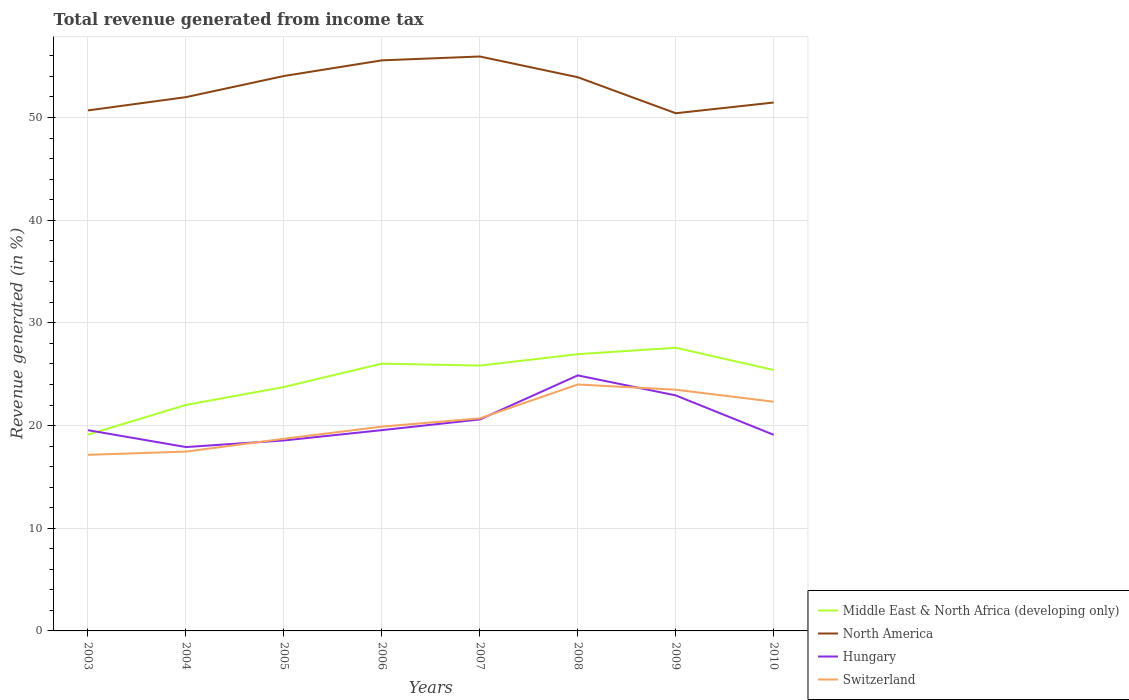Does the line corresponding to Switzerland intersect with the line corresponding to Hungary?
Your response must be concise. Yes. Across all years, what is the maximum total revenue generated in Switzerland?
Provide a short and direct response. 17.15. In which year was the total revenue generated in Middle East & North Africa (developing only) maximum?
Your response must be concise. 2003. What is the total total revenue generated in Middle East & North Africa (developing only) in the graph?
Provide a succinct answer. -0.63. What is the difference between the highest and the second highest total revenue generated in Middle East & North Africa (developing only)?
Offer a terse response. 8.46. What is the difference between the highest and the lowest total revenue generated in Hungary?
Provide a succinct answer. 3. Is the total revenue generated in North America strictly greater than the total revenue generated in Middle East & North Africa (developing only) over the years?
Your answer should be compact. No. How many lines are there?
Provide a short and direct response. 4. Are the values on the major ticks of Y-axis written in scientific E-notation?
Your answer should be very brief. No. Does the graph contain any zero values?
Your response must be concise. No. Does the graph contain grids?
Ensure brevity in your answer.  Yes. Where does the legend appear in the graph?
Keep it short and to the point. Bottom right. How are the legend labels stacked?
Make the answer very short. Vertical. What is the title of the graph?
Ensure brevity in your answer.  Total revenue generated from income tax. What is the label or title of the Y-axis?
Ensure brevity in your answer.  Revenue generated (in %). What is the Revenue generated (in %) of Middle East & North Africa (developing only) in 2003?
Make the answer very short. 19.12. What is the Revenue generated (in %) of North America in 2003?
Your answer should be compact. 50.69. What is the Revenue generated (in %) in Hungary in 2003?
Provide a succinct answer. 19.55. What is the Revenue generated (in %) of Switzerland in 2003?
Give a very brief answer. 17.15. What is the Revenue generated (in %) of Middle East & North Africa (developing only) in 2004?
Give a very brief answer. 22.01. What is the Revenue generated (in %) in North America in 2004?
Provide a short and direct response. 51.98. What is the Revenue generated (in %) in Hungary in 2004?
Offer a very short reply. 17.9. What is the Revenue generated (in %) in Switzerland in 2004?
Make the answer very short. 17.46. What is the Revenue generated (in %) in Middle East & North Africa (developing only) in 2005?
Ensure brevity in your answer.  23.75. What is the Revenue generated (in %) of North America in 2005?
Make the answer very short. 54.04. What is the Revenue generated (in %) of Hungary in 2005?
Provide a succinct answer. 18.55. What is the Revenue generated (in %) of Switzerland in 2005?
Ensure brevity in your answer.  18.71. What is the Revenue generated (in %) of Middle East & North Africa (developing only) in 2006?
Give a very brief answer. 26.03. What is the Revenue generated (in %) in North America in 2006?
Provide a short and direct response. 55.56. What is the Revenue generated (in %) in Hungary in 2006?
Offer a very short reply. 19.55. What is the Revenue generated (in %) of Switzerland in 2006?
Provide a short and direct response. 19.89. What is the Revenue generated (in %) of Middle East & North Africa (developing only) in 2007?
Provide a short and direct response. 25.84. What is the Revenue generated (in %) in North America in 2007?
Provide a succinct answer. 55.94. What is the Revenue generated (in %) of Hungary in 2007?
Keep it short and to the point. 20.59. What is the Revenue generated (in %) of Switzerland in 2007?
Keep it short and to the point. 20.7. What is the Revenue generated (in %) of Middle East & North Africa (developing only) in 2008?
Your answer should be very brief. 26.95. What is the Revenue generated (in %) in North America in 2008?
Offer a very short reply. 53.92. What is the Revenue generated (in %) in Hungary in 2008?
Ensure brevity in your answer.  24.88. What is the Revenue generated (in %) of Switzerland in 2008?
Ensure brevity in your answer.  24. What is the Revenue generated (in %) of Middle East & North Africa (developing only) in 2009?
Offer a terse response. 27.57. What is the Revenue generated (in %) of North America in 2009?
Your answer should be very brief. 50.41. What is the Revenue generated (in %) in Hungary in 2009?
Offer a terse response. 22.93. What is the Revenue generated (in %) in Switzerland in 2009?
Give a very brief answer. 23.49. What is the Revenue generated (in %) of Middle East & North Africa (developing only) in 2010?
Ensure brevity in your answer.  25.41. What is the Revenue generated (in %) of North America in 2010?
Give a very brief answer. 51.46. What is the Revenue generated (in %) in Hungary in 2010?
Your answer should be very brief. 19.1. What is the Revenue generated (in %) in Switzerland in 2010?
Your answer should be compact. 22.32. Across all years, what is the maximum Revenue generated (in %) in Middle East & North Africa (developing only)?
Provide a succinct answer. 27.57. Across all years, what is the maximum Revenue generated (in %) in North America?
Offer a very short reply. 55.94. Across all years, what is the maximum Revenue generated (in %) in Hungary?
Give a very brief answer. 24.88. Across all years, what is the maximum Revenue generated (in %) of Switzerland?
Offer a very short reply. 24. Across all years, what is the minimum Revenue generated (in %) of Middle East & North Africa (developing only)?
Offer a very short reply. 19.12. Across all years, what is the minimum Revenue generated (in %) in North America?
Offer a very short reply. 50.41. Across all years, what is the minimum Revenue generated (in %) of Hungary?
Give a very brief answer. 17.9. Across all years, what is the minimum Revenue generated (in %) in Switzerland?
Your answer should be very brief. 17.15. What is the total Revenue generated (in %) in Middle East & North Africa (developing only) in the graph?
Your answer should be very brief. 196.67. What is the total Revenue generated (in %) of North America in the graph?
Offer a terse response. 423.99. What is the total Revenue generated (in %) in Hungary in the graph?
Your answer should be very brief. 163.06. What is the total Revenue generated (in %) of Switzerland in the graph?
Offer a terse response. 163.73. What is the difference between the Revenue generated (in %) in Middle East & North Africa (developing only) in 2003 and that in 2004?
Keep it short and to the point. -2.89. What is the difference between the Revenue generated (in %) in North America in 2003 and that in 2004?
Keep it short and to the point. -1.29. What is the difference between the Revenue generated (in %) in Hungary in 2003 and that in 2004?
Your answer should be compact. 1.64. What is the difference between the Revenue generated (in %) in Switzerland in 2003 and that in 2004?
Offer a very short reply. -0.31. What is the difference between the Revenue generated (in %) in Middle East & North Africa (developing only) in 2003 and that in 2005?
Your answer should be very brief. -4.64. What is the difference between the Revenue generated (in %) in North America in 2003 and that in 2005?
Your answer should be very brief. -3.35. What is the difference between the Revenue generated (in %) in Hungary in 2003 and that in 2005?
Offer a very short reply. 1. What is the difference between the Revenue generated (in %) in Switzerland in 2003 and that in 2005?
Make the answer very short. -1.56. What is the difference between the Revenue generated (in %) in Middle East & North Africa (developing only) in 2003 and that in 2006?
Provide a short and direct response. -6.91. What is the difference between the Revenue generated (in %) in North America in 2003 and that in 2006?
Ensure brevity in your answer.  -4.88. What is the difference between the Revenue generated (in %) of Hungary in 2003 and that in 2006?
Offer a terse response. -0. What is the difference between the Revenue generated (in %) in Switzerland in 2003 and that in 2006?
Provide a short and direct response. -2.75. What is the difference between the Revenue generated (in %) of Middle East & North Africa (developing only) in 2003 and that in 2007?
Give a very brief answer. -6.72. What is the difference between the Revenue generated (in %) of North America in 2003 and that in 2007?
Make the answer very short. -5.25. What is the difference between the Revenue generated (in %) in Hungary in 2003 and that in 2007?
Your answer should be compact. -1.05. What is the difference between the Revenue generated (in %) in Switzerland in 2003 and that in 2007?
Your answer should be very brief. -3.55. What is the difference between the Revenue generated (in %) in Middle East & North Africa (developing only) in 2003 and that in 2008?
Make the answer very short. -7.83. What is the difference between the Revenue generated (in %) in North America in 2003 and that in 2008?
Ensure brevity in your answer.  -3.23. What is the difference between the Revenue generated (in %) of Hungary in 2003 and that in 2008?
Offer a terse response. -5.34. What is the difference between the Revenue generated (in %) of Switzerland in 2003 and that in 2008?
Provide a short and direct response. -6.85. What is the difference between the Revenue generated (in %) of Middle East & North Africa (developing only) in 2003 and that in 2009?
Provide a succinct answer. -8.46. What is the difference between the Revenue generated (in %) of North America in 2003 and that in 2009?
Your answer should be very brief. 0.27. What is the difference between the Revenue generated (in %) in Hungary in 2003 and that in 2009?
Offer a very short reply. -3.39. What is the difference between the Revenue generated (in %) in Switzerland in 2003 and that in 2009?
Ensure brevity in your answer.  -6.34. What is the difference between the Revenue generated (in %) in Middle East & North Africa (developing only) in 2003 and that in 2010?
Offer a terse response. -6.3. What is the difference between the Revenue generated (in %) of North America in 2003 and that in 2010?
Your answer should be compact. -0.77. What is the difference between the Revenue generated (in %) of Hungary in 2003 and that in 2010?
Provide a short and direct response. 0.45. What is the difference between the Revenue generated (in %) of Switzerland in 2003 and that in 2010?
Give a very brief answer. -5.17. What is the difference between the Revenue generated (in %) of Middle East & North Africa (developing only) in 2004 and that in 2005?
Offer a very short reply. -1.74. What is the difference between the Revenue generated (in %) of North America in 2004 and that in 2005?
Your answer should be very brief. -2.06. What is the difference between the Revenue generated (in %) in Hungary in 2004 and that in 2005?
Provide a succinct answer. -0.64. What is the difference between the Revenue generated (in %) of Switzerland in 2004 and that in 2005?
Provide a short and direct response. -1.25. What is the difference between the Revenue generated (in %) of Middle East & North Africa (developing only) in 2004 and that in 2006?
Offer a terse response. -4.02. What is the difference between the Revenue generated (in %) in North America in 2004 and that in 2006?
Provide a succinct answer. -3.58. What is the difference between the Revenue generated (in %) of Hungary in 2004 and that in 2006?
Give a very brief answer. -1.65. What is the difference between the Revenue generated (in %) in Switzerland in 2004 and that in 2006?
Provide a succinct answer. -2.43. What is the difference between the Revenue generated (in %) of Middle East & North Africa (developing only) in 2004 and that in 2007?
Ensure brevity in your answer.  -3.83. What is the difference between the Revenue generated (in %) in North America in 2004 and that in 2007?
Your response must be concise. -3.96. What is the difference between the Revenue generated (in %) of Hungary in 2004 and that in 2007?
Keep it short and to the point. -2.69. What is the difference between the Revenue generated (in %) in Switzerland in 2004 and that in 2007?
Your response must be concise. -3.24. What is the difference between the Revenue generated (in %) in Middle East & North Africa (developing only) in 2004 and that in 2008?
Keep it short and to the point. -4.94. What is the difference between the Revenue generated (in %) in North America in 2004 and that in 2008?
Your answer should be very brief. -1.94. What is the difference between the Revenue generated (in %) in Hungary in 2004 and that in 2008?
Ensure brevity in your answer.  -6.98. What is the difference between the Revenue generated (in %) of Switzerland in 2004 and that in 2008?
Provide a succinct answer. -6.54. What is the difference between the Revenue generated (in %) of Middle East & North Africa (developing only) in 2004 and that in 2009?
Keep it short and to the point. -5.57. What is the difference between the Revenue generated (in %) in North America in 2004 and that in 2009?
Give a very brief answer. 1.57. What is the difference between the Revenue generated (in %) of Hungary in 2004 and that in 2009?
Provide a short and direct response. -5.03. What is the difference between the Revenue generated (in %) in Switzerland in 2004 and that in 2009?
Offer a terse response. -6.03. What is the difference between the Revenue generated (in %) in Middle East & North Africa (developing only) in 2004 and that in 2010?
Give a very brief answer. -3.4. What is the difference between the Revenue generated (in %) of North America in 2004 and that in 2010?
Your answer should be very brief. 0.52. What is the difference between the Revenue generated (in %) in Hungary in 2004 and that in 2010?
Give a very brief answer. -1.19. What is the difference between the Revenue generated (in %) of Switzerland in 2004 and that in 2010?
Your response must be concise. -4.86. What is the difference between the Revenue generated (in %) of Middle East & North Africa (developing only) in 2005 and that in 2006?
Keep it short and to the point. -2.28. What is the difference between the Revenue generated (in %) in North America in 2005 and that in 2006?
Provide a short and direct response. -1.52. What is the difference between the Revenue generated (in %) of Hungary in 2005 and that in 2006?
Provide a succinct answer. -1. What is the difference between the Revenue generated (in %) of Switzerland in 2005 and that in 2006?
Keep it short and to the point. -1.18. What is the difference between the Revenue generated (in %) of Middle East & North Africa (developing only) in 2005 and that in 2007?
Keep it short and to the point. -2.09. What is the difference between the Revenue generated (in %) of Hungary in 2005 and that in 2007?
Provide a succinct answer. -2.05. What is the difference between the Revenue generated (in %) of Switzerland in 2005 and that in 2007?
Provide a succinct answer. -1.99. What is the difference between the Revenue generated (in %) of Middle East & North Africa (developing only) in 2005 and that in 2008?
Keep it short and to the point. -3.2. What is the difference between the Revenue generated (in %) of North America in 2005 and that in 2008?
Offer a very short reply. 0.12. What is the difference between the Revenue generated (in %) in Hungary in 2005 and that in 2008?
Your answer should be very brief. -6.34. What is the difference between the Revenue generated (in %) in Switzerland in 2005 and that in 2008?
Ensure brevity in your answer.  -5.29. What is the difference between the Revenue generated (in %) of Middle East & North Africa (developing only) in 2005 and that in 2009?
Give a very brief answer. -3.82. What is the difference between the Revenue generated (in %) of North America in 2005 and that in 2009?
Ensure brevity in your answer.  3.63. What is the difference between the Revenue generated (in %) of Hungary in 2005 and that in 2009?
Provide a short and direct response. -4.39. What is the difference between the Revenue generated (in %) in Switzerland in 2005 and that in 2009?
Make the answer very short. -4.78. What is the difference between the Revenue generated (in %) of Middle East & North Africa (developing only) in 2005 and that in 2010?
Your answer should be very brief. -1.66. What is the difference between the Revenue generated (in %) of North America in 2005 and that in 2010?
Provide a succinct answer. 2.58. What is the difference between the Revenue generated (in %) in Hungary in 2005 and that in 2010?
Your answer should be very brief. -0.55. What is the difference between the Revenue generated (in %) in Switzerland in 2005 and that in 2010?
Provide a short and direct response. -3.61. What is the difference between the Revenue generated (in %) of Middle East & North Africa (developing only) in 2006 and that in 2007?
Your response must be concise. 0.19. What is the difference between the Revenue generated (in %) in North America in 2006 and that in 2007?
Keep it short and to the point. -0.38. What is the difference between the Revenue generated (in %) in Hungary in 2006 and that in 2007?
Your answer should be compact. -1.04. What is the difference between the Revenue generated (in %) in Switzerland in 2006 and that in 2007?
Ensure brevity in your answer.  -0.81. What is the difference between the Revenue generated (in %) in Middle East & North Africa (developing only) in 2006 and that in 2008?
Your response must be concise. -0.92. What is the difference between the Revenue generated (in %) in North America in 2006 and that in 2008?
Offer a terse response. 1.64. What is the difference between the Revenue generated (in %) of Hungary in 2006 and that in 2008?
Ensure brevity in your answer.  -5.33. What is the difference between the Revenue generated (in %) in Switzerland in 2006 and that in 2008?
Provide a succinct answer. -4.1. What is the difference between the Revenue generated (in %) in Middle East & North Africa (developing only) in 2006 and that in 2009?
Keep it short and to the point. -1.55. What is the difference between the Revenue generated (in %) of North America in 2006 and that in 2009?
Provide a short and direct response. 5.15. What is the difference between the Revenue generated (in %) in Hungary in 2006 and that in 2009?
Keep it short and to the point. -3.38. What is the difference between the Revenue generated (in %) of Switzerland in 2006 and that in 2009?
Your response must be concise. -3.59. What is the difference between the Revenue generated (in %) of Middle East & North Africa (developing only) in 2006 and that in 2010?
Your answer should be compact. 0.62. What is the difference between the Revenue generated (in %) of North America in 2006 and that in 2010?
Ensure brevity in your answer.  4.11. What is the difference between the Revenue generated (in %) in Hungary in 2006 and that in 2010?
Make the answer very short. 0.45. What is the difference between the Revenue generated (in %) of Switzerland in 2006 and that in 2010?
Provide a short and direct response. -2.43. What is the difference between the Revenue generated (in %) of Middle East & North Africa (developing only) in 2007 and that in 2008?
Make the answer very short. -1.11. What is the difference between the Revenue generated (in %) of North America in 2007 and that in 2008?
Give a very brief answer. 2.02. What is the difference between the Revenue generated (in %) in Hungary in 2007 and that in 2008?
Provide a succinct answer. -4.29. What is the difference between the Revenue generated (in %) of Switzerland in 2007 and that in 2008?
Your answer should be very brief. -3.3. What is the difference between the Revenue generated (in %) of Middle East & North Africa (developing only) in 2007 and that in 2009?
Offer a very short reply. -1.74. What is the difference between the Revenue generated (in %) of North America in 2007 and that in 2009?
Your answer should be compact. 5.53. What is the difference between the Revenue generated (in %) in Hungary in 2007 and that in 2009?
Make the answer very short. -2.34. What is the difference between the Revenue generated (in %) in Switzerland in 2007 and that in 2009?
Make the answer very short. -2.79. What is the difference between the Revenue generated (in %) of Middle East & North Africa (developing only) in 2007 and that in 2010?
Provide a succinct answer. 0.43. What is the difference between the Revenue generated (in %) of North America in 2007 and that in 2010?
Keep it short and to the point. 4.48. What is the difference between the Revenue generated (in %) of Hungary in 2007 and that in 2010?
Your response must be concise. 1.5. What is the difference between the Revenue generated (in %) in Switzerland in 2007 and that in 2010?
Ensure brevity in your answer.  -1.62. What is the difference between the Revenue generated (in %) in Middle East & North Africa (developing only) in 2008 and that in 2009?
Provide a succinct answer. -0.63. What is the difference between the Revenue generated (in %) in North America in 2008 and that in 2009?
Provide a short and direct response. 3.51. What is the difference between the Revenue generated (in %) in Hungary in 2008 and that in 2009?
Give a very brief answer. 1.95. What is the difference between the Revenue generated (in %) in Switzerland in 2008 and that in 2009?
Provide a succinct answer. 0.51. What is the difference between the Revenue generated (in %) of Middle East & North Africa (developing only) in 2008 and that in 2010?
Make the answer very short. 1.54. What is the difference between the Revenue generated (in %) in North America in 2008 and that in 2010?
Your response must be concise. 2.46. What is the difference between the Revenue generated (in %) in Hungary in 2008 and that in 2010?
Your answer should be compact. 5.79. What is the difference between the Revenue generated (in %) of Switzerland in 2008 and that in 2010?
Your answer should be very brief. 1.68. What is the difference between the Revenue generated (in %) of Middle East & North Africa (developing only) in 2009 and that in 2010?
Give a very brief answer. 2.16. What is the difference between the Revenue generated (in %) of North America in 2009 and that in 2010?
Provide a short and direct response. -1.04. What is the difference between the Revenue generated (in %) in Hungary in 2009 and that in 2010?
Keep it short and to the point. 3.84. What is the difference between the Revenue generated (in %) of Switzerland in 2009 and that in 2010?
Offer a very short reply. 1.17. What is the difference between the Revenue generated (in %) in Middle East & North Africa (developing only) in 2003 and the Revenue generated (in %) in North America in 2004?
Make the answer very short. -32.86. What is the difference between the Revenue generated (in %) of Middle East & North Africa (developing only) in 2003 and the Revenue generated (in %) of Hungary in 2004?
Keep it short and to the point. 1.21. What is the difference between the Revenue generated (in %) of Middle East & North Africa (developing only) in 2003 and the Revenue generated (in %) of Switzerland in 2004?
Provide a succinct answer. 1.65. What is the difference between the Revenue generated (in %) of North America in 2003 and the Revenue generated (in %) of Hungary in 2004?
Your response must be concise. 32.78. What is the difference between the Revenue generated (in %) in North America in 2003 and the Revenue generated (in %) in Switzerland in 2004?
Ensure brevity in your answer.  33.22. What is the difference between the Revenue generated (in %) in Hungary in 2003 and the Revenue generated (in %) in Switzerland in 2004?
Your response must be concise. 2.09. What is the difference between the Revenue generated (in %) in Middle East & North Africa (developing only) in 2003 and the Revenue generated (in %) in North America in 2005?
Ensure brevity in your answer.  -34.92. What is the difference between the Revenue generated (in %) of Middle East & North Africa (developing only) in 2003 and the Revenue generated (in %) of Hungary in 2005?
Your answer should be compact. 0.57. What is the difference between the Revenue generated (in %) of Middle East & North Africa (developing only) in 2003 and the Revenue generated (in %) of Switzerland in 2005?
Make the answer very short. 0.4. What is the difference between the Revenue generated (in %) in North America in 2003 and the Revenue generated (in %) in Hungary in 2005?
Make the answer very short. 32.14. What is the difference between the Revenue generated (in %) of North America in 2003 and the Revenue generated (in %) of Switzerland in 2005?
Your answer should be very brief. 31.97. What is the difference between the Revenue generated (in %) in Hungary in 2003 and the Revenue generated (in %) in Switzerland in 2005?
Your answer should be very brief. 0.84. What is the difference between the Revenue generated (in %) of Middle East & North Africa (developing only) in 2003 and the Revenue generated (in %) of North America in 2006?
Ensure brevity in your answer.  -36.45. What is the difference between the Revenue generated (in %) in Middle East & North Africa (developing only) in 2003 and the Revenue generated (in %) in Hungary in 2006?
Keep it short and to the point. -0.44. What is the difference between the Revenue generated (in %) in Middle East & North Africa (developing only) in 2003 and the Revenue generated (in %) in Switzerland in 2006?
Your answer should be compact. -0.78. What is the difference between the Revenue generated (in %) of North America in 2003 and the Revenue generated (in %) of Hungary in 2006?
Your answer should be compact. 31.14. What is the difference between the Revenue generated (in %) of North America in 2003 and the Revenue generated (in %) of Switzerland in 2006?
Keep it short and to the point. 30.79. What is the difference between the Revenue generated (in %) in Hungary in 2003 and the Revenue generated (in %) in Switzerland in 2006?
Provide a short and direct response. -0.35. What is the difference between the Revenue generated (in %) in Middle East & North Africa (developing only) in 2003 and the Revenue generated (in %) in North America in 2007?
Give a very brief answer. -36.82. What is the difference between the Revenue generated (in %) in Middle East & North Africa (developing only) in 2003 and the Revenue generated (in %) in Hungary in 2007?
Provide a short and direct response. -1.48. What is the difference between the Revenue generated (in %) in Middle East & North Africa (developing only) in 2003 and the Revenue generated (in %) in Switzerland in 2007?
Make the answer very short. -1.58. What is the difference between the Revenue generated (in %) in North America in 2003 and the Revenue generated (in %) in Hungary in 2007?
Ensure brevity in your answer.  30.09. What is the difference between the Revenue generated (in %) of North America in 2003 and the Revenue generated (in %) of Switzerland in 2007?
Offer a very short reply. 29.99. What is the difference between the Revenue generated (in %) of Hungary in 2003 and the Revenue generated (in %) of Switzerland in 2007?
Your answer should be very brief. -1.15. What is the difference between the Revenue generated (in %) of Middle East & North Africa (developing only) in 2003 and the Revenue generated (in %) of North America in 2008?
Your response must be concise. -34.8. What is the difference between the Revenue generated (in %) of Middle East & North Africa (developing only) in 2003 and the Revenue generated (in %) of Hungary in 2008?
Ensure brevity in your answer.  -5.77. What is the difference between the Revenue generated (in %) of Middle East & North Africa (developing only) in 2003 and the Revenue generated (in %) of Switzerland in 2008?
Offer a terse response. -4.88. What is the difference between the Revenue generated (in %) in North America in 2003 and the Revenue generated (in %) in Hungary in 2008?
Your response must be concise. 25.8. What is the difference between the Revenue generated (in %) of North America in 2003 and the Revenue generated (in %) of Switzerland in 2008?
Make the answer very short. 26.69. What is the difference between the Revenue generated (in %) in Hungary in 2003 and the Revenue generated (in %) in Switzerland in 2008?
Provide a short and direct response. -4.45. What is the difference between the Revenue generated (in %) in Middle East & North Africa (developing only) in 2003 and the Revenue generated (in %) in North America in 2009?
Give a very brief answer. -31.3. What is the difference between the Revenue generated (in %) of Middle East & North Africa (developing only) in 2003 and the Revenue generated (in %) of Hungary in 2009?
Offer a terse response. -3.82. What is the difference between the Revenue generated (in %) of Middle East & North Africa (developing only) in 2003 and the Revenue generated (in %) of Switzerland in 2009?
Give a very brief answer. -4.37. What is the difference between the Revenue generated (in %) of North America in 2003 and the Revenue generated (in %) of Hungary in 2009?
Keep it short and to the point. 27.75. What is the difference between the Revenue generated (in %) in North America in 2003 and the Revenue generated (in %) in Switzerland in 2009?
Make the answer very short. 27.2. What is the difference between the Revenue generated (in %) in Hungary in 2003 and the Revenue generated (in %) in Switzerland in 2009?
Your answer should be very brief. -3.94. What is the difference between the Revenue generated (in %) of Middle East & North Africa (developing only) in 2003 and the Revenue generated (in %) of North America in 2010?
Your answer should be compact. -32.34. What is the difference between the Revenue generated (in %) of Middle East & North Africa (developing only) in 2003 and the Revenue generated (in %) of Hungary in 2010?
Provide a succinct answer. 0.02. What is the difference between the Revenue generated (in %) in Middle East & North Africa (developing only) in 2003 and the Revenue generated (in %) in Switzerland in 2010?
Provide a short and direct response. -3.21. What is the difference between the Revenue generated (in %) of North America in 2003 and the Revenue generated (in %) of Hungary in 2010?
Offer a terse response. 31.59. What is the difference between the Revenue generated (in %) of North America in 2003 and the Revenue generated (in %) of Switzerland in 2010?
Provide a succinct answer. 28.37. What is the difference between the Revenue generated (in %) of Hungary in 2003 and the Revenue generated (in %) of Switzerland in 2010?
Provide a short and direct response. -2.77. What is the difference between the Revenue generated (in %) of Middle East & North Africa (developing only) in 2004 and the Revenue generated (in %) of North America in 2005?
Offer a terse response. -32.03. What is the difference between the Revenue generated (in %) of Middle East & North Africa (developing only) in 2004 and the Revenue generated (in %) of Hungary in 2005?
Make the answer very short. 3.46. What is the difference between the Revenue generated (in %) in Middle East & North Africa (developing only) in 2004 and the Revenue generated (in %) in Switzerland in 2005?
Provide a succinct answer. 3.29. What is the difference between the Revenue generated (in %) of North America in 2004 and the Revenue generated (in %) of Hungary in 2005?
Offer a very short reply. 33.43. What is the difference between the Revenue generated (in %) of North America in 2004 and the Revenue generated (in %) of Switzerland in 2005?
Give a very brief answer. 33.27. What is the difference between the Revenue generated (in %) in Hungary in 2004 and the Revenue generated (in %) in Switzerland in 2005?
Provide a short and direct response. -0.81. What is the difference between the Revenue generated (in %) of Middle East & North Africa (developing only) in 2004 and the Revenue generated (in %) of North America in 2006?
Offer a very short reply. -33.56. What is the difference between the Revenue generated (in %) in Middle East & North Africa (developing only) in 2004 and the Revenue generated (in %) in Hungary in 2006?
Your response must be concise. 2.45. What is the difference between the Revenue generated (in %) in Middle East & North Africa (developing only) in 2004 and the Revenue generated (in %) in Switzerland in 2006?
Make the answer very short. 2.11. What is the difference between the Revenue generated (in %) of North America in 2004 and the Revenue generated (in %) of Hungary in 2006?
Your response must be concise. 32.43. What is the difference between the Revenue generated (in %) in North America in 2004 and the Revenue generated (in %) in Switzerland in 2006?
Your answer should be very brief. 32.09. What is the difference between the Revenue generated (in %) in Hungary in 2004 and the Revenue generated (in %) in Switzerland in 2006?
Ensure brevity in your answer.  -1.99. What is the difference between the Revenue generated (in %) of Middle East & North Africa (developing only) in 2004 and the Revenue generated (in %) of North America in 2007?
Your answer should be very brief. -33.93. What is the difference between the Revenue generated (in %) in Middle East & North Africa (developing only) in 2004 and the Revenue generated (in %) in Hungary in 2007?
Make the answer very short. 1.41. What is the difference between the Revenue generated (in %) in Middle East & North Africa (developing only) in 2004 and the Revenue generated (in %) in Switzerland in 2007?
Keep it short and to the point. 1.31. What is the difference between the Revenue generated (in %) in North America in 2004 and the Revenue generated (in %) in Hungary in 2007?
Provide a succinct answer. 31.39. What is the difference between the Revenue generated (in %) of North America in 2004 and the Revenue generated (in %) of Switzerland in 2007?
Provide a short and direct response. 31.28. What is the difference between the Revenue generated (in %) of Hungary in 2004 and the Revenue generated (in %) of Switzerland in 2007?
Ensure brevity in your answer.  -2.79. What is the difference between the Revenue generated (in %) of Middle East & North Africa (developing only) in 2004 and the Revenue generated (in %) of North America in 2008?
Make the answer very short. -31.91. What is the difference between the Revenue generated (in %) of Middle East & North Africa (developing only) in 2004 and the Revenue generated (in %) of Hungary in 2008?
Your answer should be compact. -2.88. What is the difference between the Revenue generated (in %) in Middle East & North Africa (developing only) in 2004 and the Revenue generated (in %) in Switzerland in 2008?
Your response must be concise. -1.99. What is the difference between the Revenue generated (in %) of North America in 2004 and the Revenue generated (in %) of Hungary in 2008?
Ensure brevity in your answer.  27.1. What is the difference between the Revenue generated (in %) in North America in 2004 and the Revenue generated (in %) in Switzerland in 2008?
Your response must be concise. 27.98. What is the difference between the Revenue generated (in %) of Hungary in 2004 and the Revenue generated (in %) of Switzerland in 2008?
Give a very brief answer. -6.09. What is the difference between the Revenue generated (in %) of Middle East & North Africa (developing only) in 2004 and the Revenue generated (in %) of North America in 2009?
Offer a very short reply. -28.41. What is the difference between the Revenue generated (in %) of Middle East & North Africa (developing only) in 2004 and the Revenue generated (in %) of Hungary in 2009?
Offer a very short reply. -0.93. What is the difference between the Revenue generated (in %) of Middle East & North Africa (developing only) in 2004 and the Revenue generated (in %) of Switzerland in 2009?
Your response must be concise. -1.48. What is the difference between the Revenue generated (in %) in North America in 2004 and the Revenue generated (in %) in Hungary in 2009?
Make the answer very short. 29.05. What is the difference between the Revenue generated (in %) of North America in 2004 and the Revenue generated (in %) of Switzerland in 2009?
Give a very brief answer. 28.49. What is the difference between the Revenue generated (in %) in Hungary in 2004 and the Revenue generated (in %) in Switzerland in 2009?
Your answer should be very brief. -5.58. What is the difference between the Revenue generated (in %) of Middle East & North Africa (developing only) in 2004 and the Revenue generated (in %) of North America in 2010?
Ensure brevity in your answer.  -29.45. What is the difference between the Revenue generated (in %) of Middle East & North Africa (developing only) in 2004 and the Revenue generated (in %) of Hungary in 2010?
Provide a succinct answer. 2.91. What is the difference between the Revenue generated (in %) of Middle East & North Africa (developing only) in 2004 and the Revenue generated (in %) of Switzerland in 2010?
Provide a succinct answer. -0.31. What is the difference between the Revenue generated (in %) in North America in 2004 and the Revenue generated (in %) in Hungary in 2010?
Offer a terse response. 32.88. What is the difference between the Revenue generated (in %) in North America in 2004 and the Revenue generated (in %) in Switzerland in 2010?
Offer a very short reply. 29.66. What is the difference between the Revenue generated (in %) of Hungary in 2004 and the Revenue generated (in %) of Switzerland in 2010?
Give a very brief answer. -4.42. What is the difference between the Revenue generated (in %) of Middle East & North Africa (developing only) in 2005 and the Revenue generated (in %) of North America in 2006?
Your answer should be very brief. -31.81. What is the difference between the Revenue generated (in %) in Middle East & North Africa (developing only) in 2005 and the Revenue generated (in %) in Hungary in 2006?
Offer a very short reply. 4.2. What is the difference between the Revenue generated (in %) of Middle East & North Africa (developing only) in 2005 and the Revenue generated (in %) of Switzerland in 2006?
Make the answer very short. 3.86. What is the difference between the Revenue generated (in %) in North America in 2005 and the Revenue generated (in %) in Hungary in 2006?
Ensure brevity in your answer.  34.49. What is the difference between the Revenue generated (in %) of North America in 2005 and the Revenue generated (in %) of Switzerland in 2006?
Your answer should be compact. 34.14. What is the difference between the Revenue generated (in %) in Hungary in 2005 and the Revenue generated (in %) in Switzerland in 2006?
Offer a very short reply. -1.35. What is the difference between the Revenue generated (in %) of Middle East & North Africa (developing only) in 2005 and the Revenue generated (in %) of North America in 2007?
Offer a terse response. -32.19. What is the difference between the Revenue generated (in %) in Middle East & North Africa (developing only) in 2005 and the Revenue generated (in %) in Hungary in 2007?
Provide a short and direct response. 3.16. What is the difference between the Revenue generated (in %) of Middle East & North Africa (developing only) in 2005 and the Revenue generated (in %) of Switzerland in 2007?
Your response must be concise. 3.05. What is the difference between the Revenue generated (in %) in North America in 2005 and the Revenue generated (in %) in Hungary in 2007?
Offer a terse response. 33.44. What is the difference between the Revenue generated (in %) of North America in 2005 and the Revenue generated (in %) of Switzerland in 2007?
Your response must be concise. 33.34. What is the difference between the Revenue generated (in %) in Hungary in 2005 and the Revenue generated (in %) in Switzerland in 2007?
Your answer should be compact. -2.15. What is the difference between the Revenue generated (in %) in Middle East & North Africa (developing only) in 2005 and the Revenue generated (in %) in North America in 2008?
Ensure brevity in your answer.  -30.17. What is the difference between the Revenue generated (in %) of Middle East & North Africa (developing only) in 2005 and the Revenue generated (in %) of Hungary in 2008?
Give a very brief answer. -1.13. What is the difference between the Revenue generated (in %) in Middle East & North Africa (developing only) in 2005 and the Revenue generated (in %) in Switzerland in 2008?
Your response must be concise. -0.25. What is the difference between the Revenue generated (in %) in North America in 2005 and the Revenue generated (in %) in Hungary in 2008?
Make the answer very short. 29.15. What is the difference between the Revenue generated (in %) in North America in 2005 and the Revenue generated (in %) in Switzerland in 2008?
Offer a very short reply. 30.04. What is the difference between the Revenue generated (in %) in Hungary in 2005 and the Revenue generated (in %) in Switzerland in 2008?
Offer a very short reply. -5.45. What is the difference between the Revenue generated (in %) of Middle East & North Africa (developing only) in 2005 and the Revenue generated (in %) of North America in 2009?
Ensure brevity in your answer.  -26.66. What is the difference between the Revenue generated (in %) of Middle East & North Africa (developing only) in 2005 and the Revenue generated (in %) of Hungary in 2009?
Your response must be concise. 0.82. What is the difference between the Revenue generated (in %) of Middle East & North Africa (developing only) in 2005 and the Revenue generated (in %) of Switzerland in 2009?
Keep it short and to the point. 0.26. What is the difference between the Revenue generated (in %) in North America in 2005 and the Revenue generated (in %) in Hungary in 2009?
Offer a very short reply. 31.1. What is the difference between the Revenue generated (in %) of North America in 2005 and the Revenue generated (in %) of Switzerland in 2009?
Give a very brief answer. 30.55. What is the difference between the Revenue generated (in %) in Hungary in 2005 and the Revenue generated (in %) in Switzerland in 2009?
Give a very brief answer. -4.94. What is the difference between the Revenue generated (in %) of Middle East & North Africa (developing only) in 2005 and the Revenue generated (in %) of North America in 2010?
Provide a succinct answer. -27.7. What is the difference between the Revenue generated (in %) of Middle East & North Africa (developing only) in 2005 and the Revenue generated (in %) of Hungary in 2010?
Ensure brevity in your answer.  4.65. What is the difference between the Revenue generated (in %) of Middle East & North Africa (developing only) in 2005 and the Revenue generated (in %) of Switzerland in 2010?
Give a very brief answer. 1.43. What is the difference between the Revenue generated (in %) in North America in 2005 and the Revenue generated (in %) in Hungary in 2010?
Ensure brevity in your answer.  34.94. What is the difference between the Revenue generated (in %) in North America in 2005 and the Revenue generated (in %) in Switzerland in 2010?
Ensure brevity in your answer.  31.72. What is the difference between the Revenue generated (in %) of Hungary in 2005 and the Revenue generated (in %) of Switzerland in 2010?
Keep it short and to the point. -3.77. What is the difference between the Revenue generated (in %) in Middle East & North Africa (developing only) in 2006 and the Revenue generated (in %) in North America in 2007?
Your answer should be compact. -29.91. What is the difference between the Revenue generated (in %) of Middle East & North Africa (developing only) in 2006 and the Revenue generated (in %) of Hungary in 2007?
Keep it short and to the point. 5.43. What is the difference between the Revenue generated (in %) in Middle East & North Africa (developing only) in 2006 and the Revenue generated (in %) in Switzerland in 2007?
Keep it short and to the point. 5.33. What is the difference between the Revenue generated (in %) of North America in 2006 and the Revenue generated (in %) of Hungary in 2007?
Ensure brevity in your answer.  34.97. What is the difference between the Revenue generated (in %) of North America in 2006 and the Revenue generated (in %) of Switzerland in 2007?
Keep it short and to the point. 34.86. What is the difference between the Revenue generated (in %) in Hungary in 2006 and the Revenue generated (in %) in Switzerland in 2007?
Keep it short and to the point. -1.15. What is the difference between the Revenue generated (in %) of Middle East & North Africa (developing only) in 2006 and the Revenue generated (in %) of North America in 2008?
Ensure brevity in your answer.  -27.89. What is the difference between the Revenue generated (in %) in Middle East & North Africa (developing only) in 2006 and the Revenue generated (in %) in Hungary in 2008?
Provide a succinct answer. 1.14. What is the difference between the Revenue generated (in %) in Middle East & North Africa (developing only) in 2006 and the Revenue generated (in %) in Switzerland in 2008?
Your answer should be compact. 2.03. What is the difference between the Revenue generated (in %) of North America in 2006 and the Revenue generated (in %) of Hungary in 2008?
Your answer should be compact. 30.68. What is the difference between the Revenue generated (in %) of North America in 2006 and the Revenue generated (in %) of Switzerland in 2008?
Offer a very short reply. 31.56. What is the difference between the Revenue generated (in %) in Hungary in 2006 and the Revenue generated (in %) in Switzerland in 2008?
Ensure brevity in your answer.  -4.45. What is the difference between the Revenue generated (in %) of Middle East & North Africa (developing only) in 2006 and the Revenue generated (in %) of North America in 2009?
Your response must be concise. -24.38. What is the difference between the Revenue generated (in %) in Middle East & North Africa (developing only) in 2006 and the Revenue generated (in %) in Hungary in 2009?
Ensure brevity in your answer.  3.09. What is the difference between the Revenue generated (in %) in Middle East & North Africa (developing only) in 2006 and the Revenue generated (in %) in Switzerland in 2009?
Your answer should be compact. 2.54. What is the difference between the Revenue generated (in %) in North America in 2006 and the Revenue generated (in %) in Hungary in 2009?
Offer a terse response. 32.63. What is the difference between the Revenue generated (in %) of North America in 2006 and the Revenue generated (in %) of Switzerland in 2009?
Provide a short and direct response. 32.07. What is the difference between the Revenue generated (in %) of Hungary in 2006 and the Revenue generated (in %) of Switzerland in 2009?
Your answer should be compact. -3.94. What is the difference between the Revenue generated (in %) of Middle East & North Africa (developing only) in 2006 and the Revenue generated (in %) of North America in 2010?
Ensure brevity in your answer.  -25.43. What is the difference between the Revenue generated (in %) in Middle East & North Africa (developing only) in 2006 and the Revenue generated (in %) in Hungary in 2010?
Give a very brief answer. 6.93. What is the difference between the Revenue generated (in %) of Middle East & North Africa (developing only) in 2006 and the Revenue generated (in %) of Switzerland in 2010?
Make the answer very short. 3.71. What is the difference between the Revenue generated (in %) in North America in 2006 and the Revenue generated (in %) in Hungary in 2010?
Keep it short and to the point. 36.46. What is the difference between the Revenue generated (in %) of North America in 2006 and the Revenue generated (in %) of Switzerland in 2010?
Offer a terse response. 33.24. What is the difference between the Revenue generated (in %) in Hungary in 2006 and the Revenue generated (in %) in Switzerland in 2010?
Offer a very short reply. -2.77. What is the difference between the Revenue generated (in %) of Middle East & North Africa (developing only) in 2007 and the Revenue generated (in %) of North America in 2008?
Keep it short and to the point. -28.08. What is the difference between the Revenue generated (in %) of Middle East & North Africa (developing only) in 2007 and the Revenue generated (in %) of Hungary in 2008?
Provide a succinct answer. 0.95. What is the difference between the Revenue generated (in %) of Middle East & North Africa (developing only) in 2007 and the Revenue generated (in %) of Switzerland in 2008?
Provide a short and direct response. 1.84. What is the difference between the Revenue generated (in %) in North America in 2007 and the Revenue generated (in %) in Hungary in 2008?
Provide a succinct answer. 31.05. What is the difference between the Revenue generated (in %) in North America in 2007 and the Revenue generated (in %) in Switzerland in 2008?
Keep it short and to the point. 31.94. What is the difference between the Revenue generated (in %) of Hungary in 2007 and the Revenue generated (in %) of Switzerland in 2008?
Offer a terse response. -3.4. What is the difference between the Revenue generated (in %) in Middle East & North Africa (developing only) in 2007 and the Revenue generated (in %) in North America in 2009?
Give a very brief answer. -24.57. What is the difference between the Revenue generated (in %) in Middle East & North Africa (developing only) in 2007 and the Revenue generated (in %) in Hungary in 2009?
Make the answer very short. 2.9. What is the difference between the Revenue generated (in %) in Middle East & North Africa (developing only) in 2007 and the Revenue generated (in %) in Switzerland in 2009?
Provide a short and direct response. 2.35. What is the difference between the Revenue generated (in %) in North America in 2007 and the Revenue generated (in %) in Hungary in 2009?
Offer a terse response. 33. What is the difference between the Revenue generated (in %) in North America in 2007 and the Revenue generated (in %) in Switzerland in 2009?
Your answer should be very brief. 32.45. What is the difference between the Revenue generated (in %) of Hungary in 2007 and the Revenue generated (in %) of Switzerland in 2009?
Your response must be concise. -2.89. What is the difference between the Revenue generated (in %) of Middle East & North Africa (developing only) in 2007 and the Revenue generated (in %) of North America in 2010?
Offer a terse response. -25.62. What is the difference between the Revenue generated (in %) in Middle East & North Africa (developing only) in 2007 and the Revenue generated (in %) in Hungary in 2010?
Give a very brief answer. 6.74. What is the difference between the Revenue generated (in %) in Middle East & North Africa (developing only) in 2007 and the Revenue generated (in %) in Switzerland in 2010?
Provide a succinct answer. 3.52. What is the difference between the Revenue generated (in %) of North America in 2007 and the Revenue generated (in %) of Hungary in 2010?
Make the answer very short. 36.84. What is the difference between the Revenue generated (in %) of North America in 2007 and the Revenue generated (in %) of Switzerland in 2010?
Give a very brief answer. 33.62. What is the difference between the Revenue generated (in %) in Hungary in 2007 and the Revenue generated (in %) in Switzerland in 2010?
Offer a terse response. -1.73. What is the difference between the Revenue generated (in %) in Middle East & North Africa (developing only) in 2008 and the Revenue generated (in %) in North America in 2009?
Keep it short and to the point. -23.46. What is the difference between the Revenue generated (in %) of Middle East & North Africa (developing only) in 2008 and the Revenue generated (in %) of Hungary in 2009?
Provide a short and direct response. 4.01. What is the difference between the Revenue generated (in %) of Middle East & North Africa (developing only) in 2008 and the Revenue generated (in %) of Switzerland in 2009?
Make the answer very short. 3.46. What is the difference between the Revenue generated (in %) in North America in 2008 and the Revenue generated (in %) in Hungary in 2009?
Your answer should be compact. 30.98. What is the difference between the Revenue generated (in %) in North America in 2008 and the Revenue generated (in %) in Switzerland in 2009?
Offer a very short reply. 30.43. What is the difference between the Revenue generated (in %) of Hungary in 2008 and the Revenue generated (in %) of Switzerland in 2009?
Provide a short and direct response. 1.4. What is the difference between the Revenue generated (in %) in Middle East & North Africa (developing only) in 2008 and the Revenue generated (in %) in North America in 2010?
Provide a succinct answer. -24.51. What is the difference between the Revenue generated (in %) of Middle East & North Africa (developing only) in 2008 and the Revenue generated (in %) of Hungary in 2010?
Your answer should be very brief. 7.85. What is the difference between the Revenue generated (in %) of Middle East & North Africa (developing only) in 2008 and the Revenue generated (in %) of Switzerland in 2010?
Keep it short and to the point. 4.63. What is the difference between the Revenue generated (in %) of North America in 2008 and the Revenue generated (in %) of Hungary in 2010?
Ensure brevity in your answer.  34.82. What is the difference between the Revenue generated (in %) of North America in 2008 and the Revenue generated (in %) of Switzerland in 2010?
Provide a short and direct response. 31.6. What is the difference between the Revenue generated (in %) in Hungary in 2008 and the Revenue generated (in %) in Switzerland in 2010?
Offer a terse response. 2.56. What is the difference between the Revenue generated (in %) of Middle East & North Africa (developing only) in 2009 and the Revenue generated (in %) of North America in 2010?
Ensure brevity in your answer.  -23.88. What is the difference between the Revenue generated (in %) of Middle East & North Africa (developing only) in 2009 and the Revenue generated (in %) of Hungary in 2010?
Keep it short and to the point. 8.48. What is the difference between the Revenue generated (in %) of Middle East & North Africa (developing only) in 2009 and the Revenue generated (in %) of Switzerland in 2010?
Your answer should be very brief. 5.25. What is the difference between the Revenue generated (in %) in North America in 2009 and the Revenue generated (in %) in Hungary in 2010?
Offer a terse response. 31.31. What is the difference between the Revenue generated (in %) in North America in 2009 and the Revenue generated (in %) in Switzerland in 2010?
Provide a succinct answer. 28.09. What is the difference between the Revenue generated (in %) in Hungary in 2009 and the Revenue generated (in %) in Switzerland in 2010?
Your answer should be compact. 0.61. What is the average Revenue generated (in %) of Middle East & North Africa (developing only) per year?
Provide a short and direct response. 24.58. What is the average Revenue generated (in %) of North America per year?
Your answer should be very brief. 53. What is the average Revenue generated (in %) in Hungary per year?
Keep it short and to the point. 20.38. What is the average Revenue generated (in %) of Switzerland per year?
Provide a succinct answer. 20.47. In the year 2003, what is the difference between the Revenue generated (in %) of Middle East & North Africa (developing only) and Revenue generated (in %) of North America?
Provide a short and direct response. -31.57. In the year 2003, what is the difference between the Revenue generated (in %) of Middle East & North Africa (developing only) and Revenue generated (in %) of Hungary?
Ensure brevity in your answer.  -0.43. In the year 2003, what is the difference between the Revenue generated (in %) in Middle East & North Africa (developing only) and Revenue generated (in %) in Switzerland?
Provide a succinct answer. 1.97. In the year 2003, what is the difference between the Revenue generated (in %) of North America and Revenue generated (in %) of Hungary?
Provide a succinct answer. 31.14. In the year 2003, what is the difference between the Revenue generated (in %) of North America and Revenue generated (in %) of Switzerland?
Provide a short and direct response. 33.54. In the year 2003, what is the difference between the Revenue generated (in %) of Hungary and Revenue generated (in %) of Switzerland?
Your answer should be very brief. 2.4. In the year 2004, what is the difference between the Revenue generated (in %) in Middle East & North Africa (developing only) and Revenue generated (in %) in North America?
Ensure brevity in your answer.  -29.97. In the year 2004, what is the difference between the Revenue generated (in %) in Middle East & North Africa (developing only) and Revenue generated (in %) in Hungary?
Keep it short and to the point. 4.1. In the year 2004, what is the difference between the Revenue generated (in %) of Middle East & North Africa (developing only) and Revenue generated (in %) of Switzerland?
Provide a short and direct response. 4.54. In the year 2004, what is the difference between the Revenue generated (in %) of North America and Revenue generated (in %) of Hungary?
Give a very brief answer. 34.08. In the year 2004, what is the difference between the Revenue generated (in %) in North America and Revenue generated (in %) in Switzerland?
Ensure brevity in your answer.  34.52. In the year 2004, what is the difference between the Revenue generated (in %) in Hungary and Revenue generated (in %) in Switzerland?
Ensure brevity in your answer.  0.44. In the year 2005, what is the difference between the Revenue generated (in %) of Middle East & North Africa (developing only) and Revenue generated (in %) of North America?
Provide a short and direct response. -30.29. In the year 2005, what is the difference between the Revenue generated (in %) in Middle East & North Africa (developing only) and Revenue generated (in %) in Hungary?
Your answer should be compact. 5.2. In the year 2005, what is the difference between the Revenue generated (in %) in Middle East & North Africa (developing only) and Revenue generated (in %) in Switzerland?
Give a very brief answer. 5.04. In the year 2005, what is the difference between the Revenue generated (in %) of North America and Revenue generated (in %) of Hungary?
Your answer should be very brief. 35.49. In the year 2005, what is the difference between the Revenue generated (in %) in North America and Revenue generated (in %) in Switzerland?
Make the answer very short. 35.33. In the year 2005, what is the difference between the Revenue generated (in %) in Hungary and Revenue generated (in %) in Switzerland?
Keep it short and to the point. -0.17. In the year 2006, what is the difference between the Revenue generated (in %) of Middle East & North Africa (developing only) and Revenue generated (in %) of North America?
Provide a succinct answer. -29.53. In the year 2006, what is the difference between the Revenue generated (in %) of Middle East & North Africa (developing only) and Revenue generated (in %) of Hungary?
Ensure brevity in your answer.  6.48. In the year 2006, what is the difference between the Revenue generated (in %) in Middle East & North Africa (developing only) and Revenue generated (in %) in Switzerland?
Ensure brevity in your answer.  6.13. In the year 2006, what is the difference between the Revenue generated (in %) in North America and Revenue generated (in %) in Hungary?
Ensure brevity in your answer.  36.01. In the year 2006, what is the difference between the Revenue generated (in %) in North America and Revenue generated (in %) in Switzerland?
Provide a succinct answer. 35.67. In the year 2006, what is the difference between the Revenue generated (in %) of Hungary and Revenue generated (in %) of Switzerland?
Your answer should be very brief. -0.34. In the year 2007, what is the difference between the Revenue generated (in %) in Middle East & North Africa (developing only) and Revenue generated (in %) in North America?
Your answer should be compact. -30.1. In the year 2007, what is the difference between the Revenue generated (in %) in Middle East & North Africa (developing only) and Revenue generated (in %) in Hungary?
Provide a succinct answer. 5.24. In the year 2007, what is the difference between the Revenue generated (in %) in Middle East & North Africa (developing only) and Revenue generated (in %) in Switzerland?
Your answer should be compact. 5.14. In the year 2007, what is the difference between the Revenue generated (in %) of North America and Revenue generated (in %) of Hungary?
Provide a short and direct response. 35.34. In the year 2007, what is the difference between the Revenue generated (in %) of North America and Revenue generated (in %) of Switzerland?
Provide a succinct answer. 35.24. In the year 2007, what is the difference between the Revenue generated (in %) in Hungary and Revenue generated (in %) in Switzerland?
Your answer should be very brief. -0.1. In the year 2008, what is the difference between the Revenue generated (in %) in Middle East & North Africa (developing only) and Revenue generated (in %) in North America?
Provide a succinct answer. -26.97. In the year 2008, what is the difference between the Revenue generated (in %) in Middle East & North Africa (developing only) and Revenue generated (in %) in Hungary?
Keep it short and to the point. 2.06. In the year 2008, what is the difference between the Revenue generated (in %) in Middle East & North Africa (developing only) and Revenue generated (in %) in Switzerland?
Keep it short and to the point. 2.95. In the year 2008, what is the difference between the Revenue generated (in %) of North America and Revenue generated (in %) of Hungary?
Offer a terse response. 29.03. In the year 2008, what is the difference between the Revenue generated (in %) in North America and Revenue generated (in %) in Switzerland?
Your answer should be compact. 29.92. In the year 2008, what is the difference between the Revenue generated (in %) of Hungary and Revenue generated (in %) of Switzerland?
Your answer should be compact. 0.89. In the year 2009, what is the difference between the Revenue generated (in %) of Middle East & North Africa (developing only) and Revenue generated (in %) of North America?
Ensure brevity in your answer.  -22.84. In the year 2009, what is the difference between the Revenue generated (in %) in Middle East & North Africa (developing only) and Revenue generated (in %) in Hungary?
Give a very brief answer. 4.64. In the year 2009, what is the difference between the Revenue generated (in %) of Middle East & North Africa (developing only) and Revenue generated (in %) of Switzerland?
Keep it short and to the point. 4.09. In the year 2009, what is the difference between the Revenue generated (in %) in North America and Revenue generated (in %) in Hungary?
Make the answer very short. 27.48. In the year 2009, what is the difference between the Revenue generated (in %) in North America and Revenue generated (in %) in Switzerland?
Provide a succinct answer. 26.92. In the year 2009, what is the difference between the Revenue generated (in %) in Hungary and Revenue generated (in %) in Switzerland?
Provide a short and direct response. -0.55. In the year 2010, what is the difference between the Revenue generated (in %) in Middle East & North Africa (developing only) and Revenue generated (in %) in North America?
Your answer should be very brief. -26.05. In the year 2010, what is the difference between the Revenue generated (in %) of Middle East & North Africa (developing only) and Revenue generated (in %) of Hungary?
Make the answer very short. 6.31. In the year 2010, what is the difference between the Revenue generated (in %) of Middle East & North Africa (developing only) and Revenue generated (in %) of Switzerland?
Provide a short and direct response. 3.09. In the year 2010, what is the difference between the Revenue generated (in %) in North America and Revenue generated (in %) in Hungary?
Make the answer very short. 32.36. In the year 2010, what is the difference between the Revenue generated (in %) in North America and Revenue generated (in %) in Switzerland?
Give a very brief answer. 29.14. In the year 2010, what is the difference between the Revenue generated (in %) of Hungary and Revenue generated (in %) of Switzerland?
Your response must be concise. -3.22. What is the ratio of the Revenue generated (in %) of Middle East & North Africa (developing only) in 2003 to that in 2004?
Provide a succinct answer. 0.87. What is the ratio of the Revenue generated (in %) of North America in 2003 to that in 2004?
Provide a succinct answer. 0.98. What is the ratio of the Revenue generated (in %) in Hungary in 2003 to that in 2004?
Your answer should be very brief. 1.09. What is the ratio of the Revenue generated (in %) of Switzerland in 2003 to that in 2004?
Keep it short and to the point. 0.98. What is the ratio of the Revenue generated (in %) of Middle East & North Africa (developing only) in 2003 to that in 2005?
Offer a terse response. 0.8. What is the ratio of the Revenue generated (in %) in North America in 2003 to that in 2005?
Your response must be concise. 0.94. What is the ratio of the Revenue generated (in %) in Hungary in 2003 to that in 2005?
Keep it short and to the point. 1.05. What is the ratio of the Revenue generated (in %) in Switzerland in 2003 to that in 2005?
Ensure brevity in your answer.  0.92. What is the ratio of the Revenue generated (in %) in Middle East & North Africa (developing only) in 2003 to that in 2006?
Offer a terse response. 0.73. What is the ratio of the Revenue generated (in %) in North America in 2003 to that in 2006?
Offer a very short reply. 0.91. What is the ratio of the Revenue generated (in %) in Switzerland in 2003 to that in 2006?
Provide a short and direct response. 0.86. What is the ratio of the Revenue generated (in %) in Middle East & North Africa (developing only) in 2003 to that in 2007?
Offer a terse response. 0.74. What is the ratio of the Revenue generated (in %) of North America in 2003 to that in 2007?
Offer a very short reply. 0.91. What is the ratio of the Revenue generated (in %) in Hungary in 2003 to that in 2007?
Your answer should be very brief. 0.95. What is the ratio of the Revenue generated (in %) in Switzerland in 2003 to that in 2007?
Give a very brief answer. 0.83. What is the ratio of the Revenue generated (in %) of Middle East & North Africa (developing only) in 2003 to that in 2008?
Provide a short and direct response. 0.71. What is the ratio of the Revenue generated (in %) in North America in 2003 to that in 2008?
Keep it short and to the point. 0.94. What is the ratio of the Revenue generated (in %) of Hungary in 2003 to that in 2008?
Make the answer very short. 0.79. What is the ratio of the Revenue generated (in %) in Switzerland in 2003 to that in 2008?
Offer a terse response. 0.71. What is the ratio of the Revenue generated (in %) in Middle East & North Africa (developing only) in 2003 to that in 2009?
Provide a succinct answer. 0.69. What is the ratio of the Revenue generated (in %) in North America in 2003 to that in 2009?
Offer a terse response. 1.01. What is the ratio of the Revenue generated (in %) of Hungary in 2003 to that in 2009?
Provide a succinct answer. 0.85. What is the ratio of the Revenue generated (in %) of Switzerland in 2003 to that in 2009?
Your answer should be very brief. 0.73. What is the ratio of the Revenue generated (in %) in Middle East & North Africa (developing only) in 2003 to that in 2010?
Your response must be concise. 0.75. What is the ratio of the Revenue generated (in %) in North America in 2003 to that in 2010?
Give a very brief answer. 0.99. What is the ratio of the Revenue generated (in %) of Hungary in 2003 to that in 2010?
Your answer should be very brief. 1.02. What is the ratio of the Revenue generated (in %) of Switzerland in 2003 to that in 2010?
Your answer should be compact. 0.77. What is the ratio of the Revenue generated (in %) in Middle East & North Africa (developing only) in 2004 to that in 2005?
Ensure brevity in your answer.  0.93. What is the ratio of the Revenue generated (in %) of North America in 2004 to that in 2005?
Your response must be concise. 0.96. What is the ratio of the Revenue generated (in %) of Hungary in 2004 to that in 2005?
Ensure brevity in your answer.  0.97. What is the ratio of the Revenue generated (in %) of Switzerland in 2004 to that in 2005?
Provide a short and direct response. 0.93. What is the ratio of the Revenue generated (in %) in Middle East & North Africa (developing only) in 2004 to that in 2006?
Your answer should be compact. 0.85. What is the ratio of the Revenue generated (in %) in North America in 2004 to that in 2006?
Your answer should be compact. 0.94. What is the ratio of the Revenue generated (in %) in Hungary in 2004 to that in 2006?
Offer a terse response. 0.92. What is the ratio of the Revenue generated (in %) of Switzerland in 2004 to that in 2006?
Ensure brevity in your answer.  0.88. What is the ratio of the Revenue generated (in %) of Middle East & North Africa (developing only) in 2004 to that in 2007?
Offer a very short reply. 0.85. What is the ratio of the Revenue generated (in %) of North America in 2004 to that in 2007?
Offer a terse response. 0.93. What is the ratio of the Revenue generated (in %) in Hungary in 2004 to that in 2007?
Give a very brief answer. 0.87. What is the ratio of the Revenue generated (in %) in Switzerland in 2004 to that in 2007?
Provide a succinct answer. 0.84. What is the ratio of the Revenue generated (in %) in Middle East & North Africa (developing only) in 2004 to that in 2008?
Make the answer very short. 0.82. What is the ratio of the Revenue generated (in %) in North America in 2004 to that in 2008?
Your answer should be compact. 0.96. What is the ratio of the Revenue generated (in %) of Hungary in 2004 to that in 2008?
Your response must be concise. 0.72. What is the ratio of the Revenue generated (in %) of Switzerland in 2004 to that in 2008?
Your answer should be compact. 0.73. What is the ratio of the Revenue generated (in %) in Middle East & North Africa (developing only) in 2004 to that in 2009?
Provide a short and direct response. 0.8. What is the ratio of the Revenue generated (in %) in North America in 2004 to that in 2009?
Give a very brief answer. 1.03. What is the ratio of the Revenue generated (in %) of Hungary in 2004 to that in 2009?
Your response must be concise. 0.78. What is the ratio of the Revenue generated (in %) of Switzerland in 2004 to that in 2009?
Offer a very short reply. 0.74. What is the ratio of the Revenue generated (in %) in Middle East & North Africa (developing only) in 2004 to that in 2010?
Offer a very short reply. 0.87. What is the ratio of the Revenue generated (in %) in North America in 2004 to that in 2010?
Provide a short and direct response. 1.01. What is the ratio of the Revenue generated (in %) of Hungary in 2004 to that in 2010?
Offer a terse response. 0.94. What is the ratio of the Revenue generated (in %) of Switzerland in 2004 to that in 2010?
Provide a short and direct response. 0.78. What is the ratio of the Revenue generated (in %) in Middle East & North Africa (developing only) in 2005 to that in 2006?
Keep it short and to the point. 0.91. What is the ratio of the Revenue generated (in %) in North America in 2005 to that in 2006?
Provide a short and direct response. 0.97. What is the ratio of the Revenue generated (in %) of Hungary in 2005 to that in 2006?
Your answer should be very brief. 0.95. What is the ratio of the Revenue generated (in %) in Switzerland in 2005 to that in 2006?
Your answer should be very brief. 0.94. What is the ratio of the Revenue generated (in %) in Middle East & North Africa (developing only) in 2005 to that in 2007?
Give a very brief answer. 0.92. What is the ratio of the Revenue generated (in %) of North America in 2005 to that in 2007?
Keep it short and to the point. 0.97. What is the ratio of the Revenue generated (in %) in Hungary in 2005 to that in 2007?
Give a very brief answer. 0.9. What is the ratio of the Revenue generated (in %) in Switzerland in 2005 to that in 2007?
Your answer should be compact. 0.9. What is the ratio of the Revenue generated (in %) of Middle East & North Africa (developing only) in 2005 to that in 2008?
Make the answer very short. 0.88. What is the ratio of the Revenue generated (in %) in Hungary in 2005 to that in 2008?
Offer a terse response. 0.75. What is the ratio of the Revenue generated (in %) of Switzerland in 2005 to that in 2008?
Give a very brief answer. 0.78. What is the ratio of the Revenue generated (in %) in Middle East & North Africa (developing only) in 2005 to that in 2009?
Make the answer very short. 0.86. What is the ratio of the Revenue generated (in %) in North America in 2005 to that in 2009?
Make the answer very short. 1.07. What is the ratio of the Revenue generated (in %) in Hungary in 2005 to that in 2009?
Offer a terse response. 0.81. What is the ratio of the Revenue generated (in %) of Switzerland in 2005 to that in 2009?
Your response must be concise. 0.8. What is the ratio of the Revenue generated (in %) of Middle East & North Africa (developing only) in 2005 to that in 2010?
Offer a very short reply. 0.93. What is the ratio of the Revenue generated (in %) of North America in 2005 to that in 2010?
Your response must be concise. 1.05. What is the ratio of the Revenue generated (in %) in Hungary in 2005 to that in 2010?
Ensure brevity in your answer.  0.97. What is the ratio of the Revenue generated (in %) of Switzerland in 2005 to that in 2010?
Your response must be concise. 0.84. What is the ratio of the Revenue generated (in %) in Middle East & North Africa (developing only) in 2006 to that in 2007?
Provide a succinct answer. 1.01. What is the ratio of the Revenue generated (in %) of North America in 2006 to that in 2007?
Your answer should be compact. 0.99. What is the ratio of the Revenue generated (in %) in Hungary in 2006 to that in 2007?
Your answer should be very brief. 0.95. What is the ratio of the Revenue generated (in %) of Switzerland in 2006 to that in 2007?
Ensure brevity in your answer.  0.96. What is the ratio of the Revenue generated (in %) of Middle East & North Africa (developing only) in 2006 to that in 2008?
Keep it short and to the point. 0.97. What is the ratio of the Revenue generated (in %) in North America in 2006 to that in 2008?
Your answer should be compact. 1.03. What is the ratio of the Revenue generated (in %) of Hungary in 2006 to that in 2008?
Your answer should be very brief. 0.79. What is the ratio of the Revenue generated (in %) in Switzerland in 2006 to that in 2008?
Provide a succinct answer. 0.83. What is the ratio of the Revenue generated (in %) of Middle East & North Africa (developing only) in 2006 to that in 2009?
Give a very brief answer. 0.94. What is the ratio of the Revenue generated (in %) in North America in 2006 to that in 2009?
Provide a succinct answer. 1.1. What is the ratio of the Revenue generated (in %) in Hungary in 2006 to that in 2009?
Make the answer very short. 0.85. What is the ratio of the Revenue generated (in %) of Switzerland in 2006 to that in 2009?
Make the answer very short. 0.85. What is the ratio of the Revenue generated (in %) of Middle East & North Africa (developing only) in 2006 to that in 2010?
Keep it short and to the point. 1.02. What is the ratio of the Revenue generated (in %) of North America in 2006 to that in 2010?
Keep it short and to the point. 1.08. What is the ratio of the Revenue generated (in %) of Hungary in 2006 to that in 2010?
Offer a very short reply. 1.02. What is the ratio of the Revenue generated (in %) of Switzerland in 2006 to that in 2010?
Offer a very short reply. 0.89. What is the ratio of the Revenue generated (in %) in Middle East & North Africa (developing only) in 2007 to that in 2008?
Your answer should be very brief. 0.96. What is the ratio of the Revenue generated (in %) in North America in 2007 to that in 2008?
Ensure brevity in your answer.  1.04. What is the ratio of the Revenue generated (in %) of Hungary in 2007 to that in 2008?
Provide a short and direct response. 0.83. What is the ratio of the Revenue generated (in %) in Switzerland in 2007 to that in 2008?
Provide a short and direct response. 0.86. What is the ratio of the Revenue generated (in %) in Middle East & North Africa (developing only) in 2007 to that in 2009?
Offer a very short reply. 0.94. What is the ratio of the Revenue generated (in %) of North America in 2007 to that in 2009?
Ensure brevity in your answer.  1.11. What is the ratio of the Revenue generated (in %) of Hungary in 2007 to that in 2009?
Provide a succinct answer. 0.9. What is the ratio of the Revenue generated (in %) of Switzerland in 2007 to that in 2009?
Provide a short and direct response. 0.88. What is the ratio of the Revenue generated (in %) in Middle East & North Africa (developing only) in 2007 to that in 2010?
Provide a short and direct response. 1.02. What is the ratio of the Revenue generated (in %) of North America in 2007 to that in 2010?
Give a very brief answer. 1.09. What is the ratio of the Revenue generated (in %) of Hungary in 2007 to that in 2010?
Ensure brevity in your answer.  1.08. What is the ratio of the Revenue generated (in %) in Switzerland in 2007 to that in 2010?
Your response must be concise. 0.93. What is the ratio of the Revenue generated (in %) in Middle East & North Africa (developing only) in 2008 to that in 2009?
Make the answer very short. 0.98. What is the ratio of the Revenue generated (in %) of North America in 2008 to that in 2009?
Offer a very short reply. 1.07. What is the ratio of the Revenue generated (in %) of Hungary in 2008 to that in 2009?
Give a very brief answer. 1.08. What is the ratio of the Revenue generated (in %) of Switzerland in 2008 to that in 2009?
Keep it short and to the point. 1.02. What is the ratio of the Revenue generated (in %) in Middle East & North Africa (developing only) in 2008 to that in 2010?
Make the answer very short. 1.06. What is the ratio of the Revenue generated (in %) of North America in 2008 to that in 2010?
Give a very brief answer. 1.05. What is the ratio of the Revenue generated (in %) in Hungary in 2008 to that in 2010?
Your answer should be very brief. 1.3. What is the ratio of the Revenue generated (in %) of Switzerland in 2008 to that in 2010?
Provide a succinct answer. 1.08. What is the ratio of the Revenue generated (in %) in Middle East & North Africa (developing only) in 2009 to that in 2010?
Provide a succinct answer. 1.09. What is the ratio of the Revenue generated (in %) of North America in 2009 to that in 2010?
Make the answer very short. 0.98. What is the ratio of the Revenue generated (in %) in Hungary in 2009 to that in 2010?
Your response must be concise. 1.2. What is the ratio of the Revenue generated (in %) of Switzerland in 2009 to that in 2010?
Your response must be concise. 1.05. What is the difference between the highest and the second highest Revenue generated (in %) in Middle East & North Africa (developing only)?
Provide a succinct answer. 0.63. What is the difference between the highest and the second highest Revenue generated (in %) in North America?
Provide a short and direct response. 0.38. What is the difference between the highest and the second highest Revenue generated (in %) of Hungary?
Provide a short and direct response. 1.95. What is the difference between the highest and the second highest Revenue generated (in %) in Switzerland?
Provide a short and direct response. 0.51. What is the difference between the highest and the lowest Revenue generated (in %) in Middle East & North Africa (developing only)?
Your response must be concise. 8.46. What is the difference between the highest and the lowest Revenue generated (in %) of North America?
Your response must be concise. 5.53. What is the difference between the highest and the lowest Revenue generated (in %) of Hungary?
Your answer should be compact. 6.98. What is the difference between the highest and the lowest Revenue generated (in %) of Switzerland?
Provide a short and direct response. 6.85. 